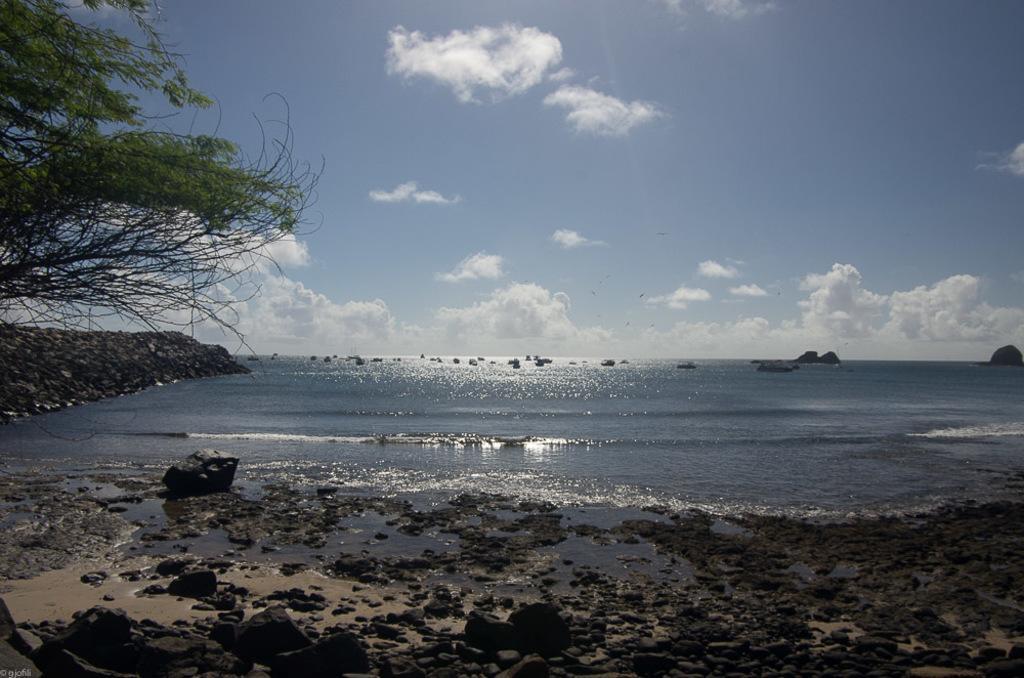Can you describe this image briefly? This image is taken at the beach. In this image we can see the rocks, stones, water and also the sand. On the left we can see the tree. In the background we can see the sky with the clouds. In the bottom left corner we can see the text. 